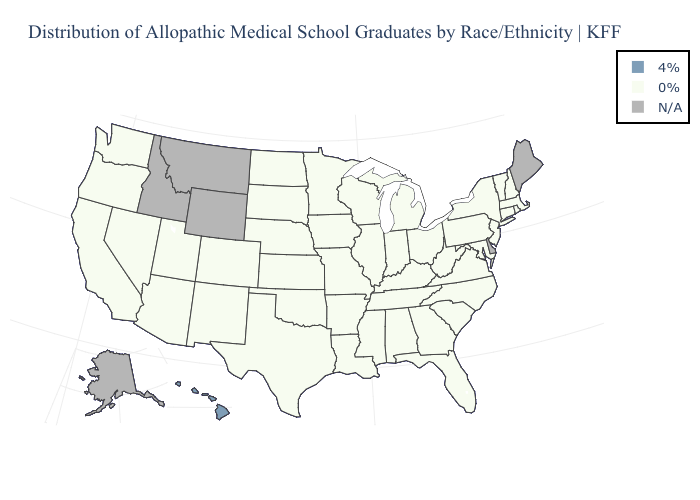Name the states that have a value in the range 0%?
Concise answer only. Alabama, Arizona, Arkansas, California, Colorado, Connecticut, Florida, Georgia, Illinois, Indiana, Iowa, Kansas, Kentucky, Louisiana, Maryland, Massachusetts, Michigan, Minnesota, Mississippi, Missouri, Nebraska, Nevada, New Hampshire, New Jersey, New Mexico, New York, North Carolina, North Dakota, Ohio, Oklahoma, Oregon, Pennsylvania, Rhode Island, South Carolina, South Dakota, Tennessee, Texas, Utah, Vermont, Virginia, Washington, West Virginia, Wisconsin. What is the highest value in states that border Alabama?
Quick response, please. 0%. Name the states that have a value in the range N/A?
Give a very brief answer. Alaska, Delaware, Idaho, Maine, Montana, Wyoming. Which states hav the highest value in the West?
Write a very short answer. Hawaii. Name the states that have a value in the range 4%?
Short answer required. Hawaii. Does the first symbol in the legend represent the smallest category?
Be succinct. No. Which states hav the highest value in the West?
Concise answer only. Hawaii. Name the states that have a value in the range 0%?
Concise answer only. Alabama, Arizona, Arkansas, California, Colorado, Connecticut, Florida, Georgia, Illinois, Indiana, Iowa, Kansas, Kentucky, Louisiana, Maryland, Massachusetts, Michigan, Minnesota, Mississippi, Missouri, Nebraska, Nevada, New Hampshire, New Jersey, New Mexico, New York, North Carolina, North Dakota, Ohio, Oklahoma, Oregon, Pennsylvania, Rhode Island, South Carolina, South Dakota, Tennessee, Texas, Utah, Vermont, Virginia, Washington, West Virginia, Wisconsin. Which states have the lowest value in the USA?
Quick response, please. Alabama, Arizona, Arkansas, California, Colorado, Connecticut, Florida, Georgia, Illinois, Indiana, Iowa, Kansas, Kentucky, Louisiana, Maryland, Massachusetts, Michigan, Minnesota, Mississippi, Missouri, Nebraska, Nevada, New Hampshire, New Jersey, New Mexico, New York, North Carolina, North Dakota, Ohio, Oklahoma, Oregon, Pennsylvania, Rhode Island, South Carolina, South Dakota, Tennessee, Texas, Utah, Vermont, Virginia, Washington, West Virginia, Wisconsin. Which states have the lowest value in the USA?
Answer briefly. Alabama, Arizona, Arkansas, California, Colorado, Connecticut, Florida, Georgia, Illinois, Indiana, Iowa, Kansas, Kentucky, Louisiana, Maryland, Massachusetts, Michigan, Minnesota, Mississippi, Missouri, Nebraska, Nevada, New Hampshire, New Jersey, New Mexico, New York, North Carolina, North Dakota, Ohio, Oklahoma, Oregon, Pennsylvania, Rhode Island, South Carolina, South Dakota, Tennessee, Texas, Utah, Vermont, Virginia, Washington, West Virginia, Wisconsin. What is the highest value in the USA?
Be succinct. 4%. What is the value of Nebraska?
Be succinct. 0%. 